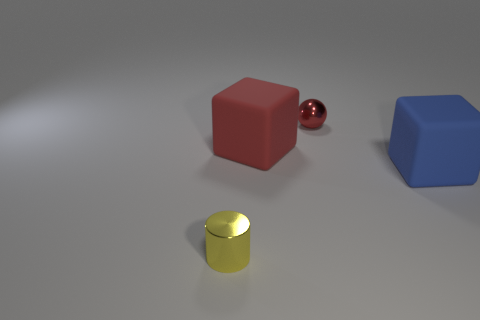How many things are yellow metallic objects or small shiny objects behind the small yellow cylinder?
Ensure brevity in your answer.  2. Is the number of big red matte things that are behind the red block less than the number of metal cylinders behind the tiny red metal sphere?
Give a very brief answer. No. How many other things are the same material as the yellow cylinder?
Offer a very short reply. 1. There is a large matte block to the left of the ball; does it have the same color as the tiny cylinder?
Make the answer very short. No. Are there any red metal things behind the tiny shiny thing that is to the right of the cylinder?
Your response must be concise. No. There is a object that is both to the left of the small red metallic sphere and right of the tiny yellow thing; what material is it?
Keep it short and to the point. Rubber. There is a object that is the same material as the tiny cylinder; what is its shape?
Provide a short and direct response. Sphere. Is there anything else that has the same shape as the blue matte thing?
Give a very brief answer. Yes. Are the tiny thing that is behind the shiny cylinder and the big blue cube made of the same material?
Provide a short and direct response. No. There is a tiny thing that is behind the tiny yellow object; what material is it?
Make the answer very short. Metal. 